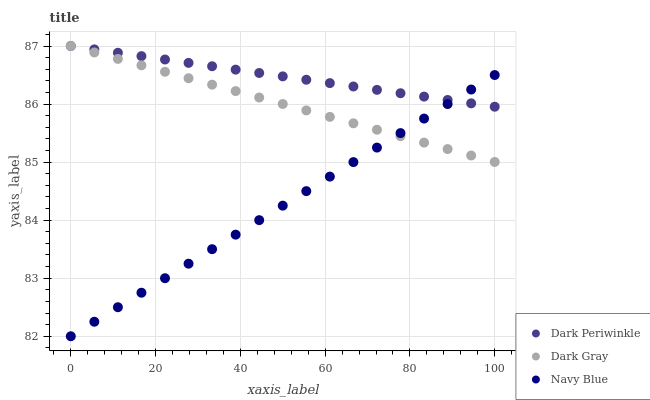Does Navy Blue have the minimum area under the curve?
Answer yes or no. Yes. Does Dark Periwinkle have the maximum area under the curve?
Answer yes or no. Yes. Does Dark Periwinkle have the minimum area under the curve?
Answer yes or no. No. Does Navy Blue have the maximum area under the curve?
Answer yes or no. No. Is Dark Gray the smoothest?
Answer yes or no. Yes. Is Dark Periwinkle the roughest?
Answer yes or no. Yes. Is Navy Blue the smoothest?
Answer yes or no. No. Is Navy Blue the roughest?
Answer yes or no. No. Does Navy Blue have the lowest value?
Answer yes or no. Yes. Does Dark Periwinkle have the lowest value?
Answer yes or no. No. Does Dark Periwinkle have the highest value?
Answer yes or no. Yes. Does Navy Blue have the highest value?
Answer yes or no. No. Does Dark Periwinkle intersect Dark Gray?
Answer yes or no. Yes. Is Dark Periwinkle less than Dark Gray?
Answer yes or no. No. Is Dark Periwinkle greater than Dark Gray?
Answer yes or no. No. 